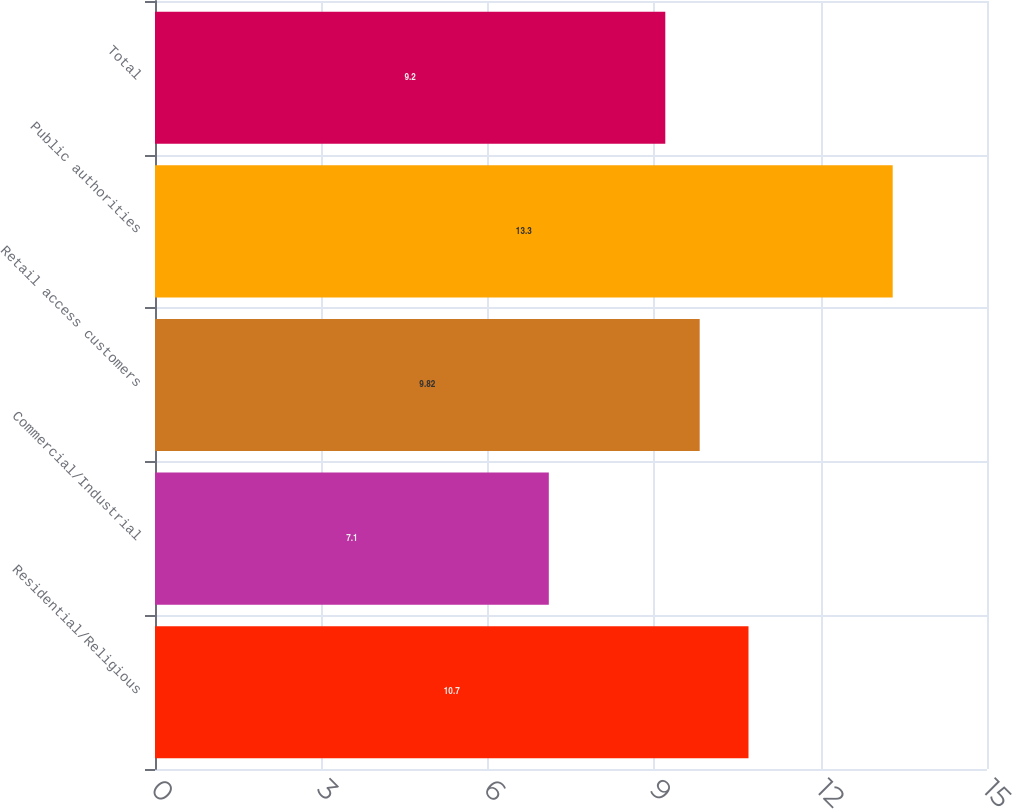<chart> <loc_0><loc_0><loc_500><loc_500><bar_chart><fcel>Residential/Religious<fcel>Commercial/Industrial<fcel>Retail access customers<fcel>Public authorities<fcel>Total<nl><fcel>10.7<fcel>7.1<fcel>9.82<fcel>13.3<fcel>9.2<nl></chart> 